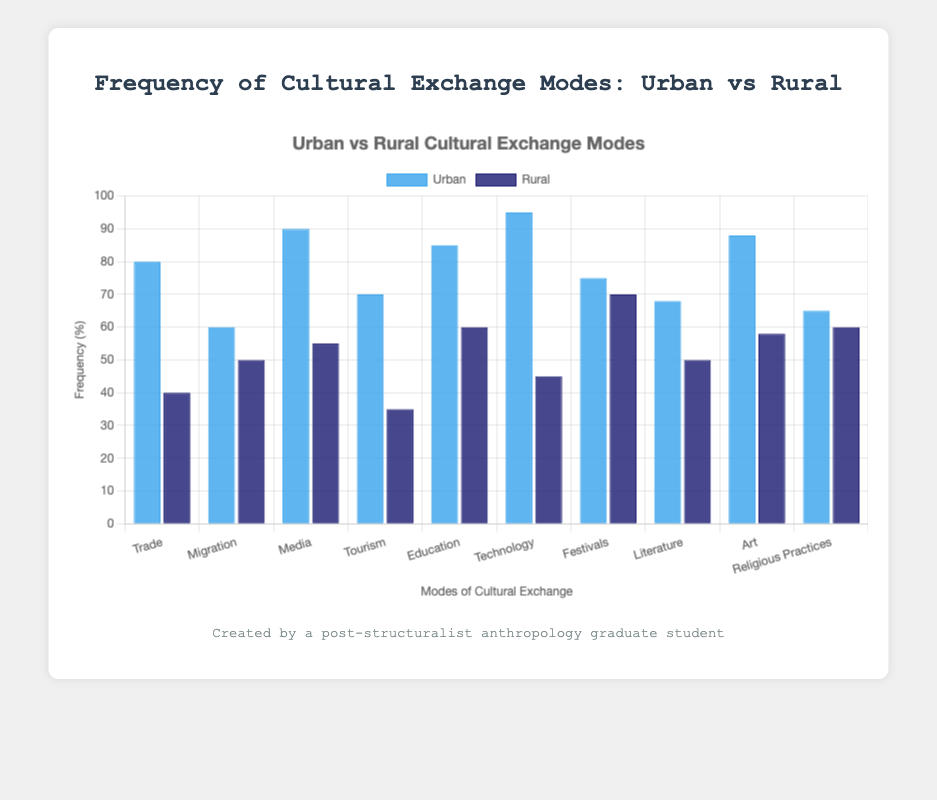What's the most frequent mode of cultural exchange in urban communities? The highest bar in the 'Urban' dataset corresponds to the mode with the greatest frequency. In this case, 'Technology' has a frequency of 95.
Answer: Technology What's the difference in the frequency of Media between urban and rural communities? To determine the difference, subtract the rural frequency from the urban frequency for the Media mode: 90 (urban) - 55 (rural) = 35.
Answer: 35 Which mode of cultural exchange has the least difference in frequency between urban and rural communities? Compare the absolute differences between the urban and rural frequencies across all modes. 'Festivals' has the least difference:
Answer: 5 How many modes have a higher frequency of cultural exchange in urban communities compared to rural communities? Count the number of modes where the urban bar is higher than the rural bar. This occurs in 'Trade', 'Media', 'Tourism', 'Education', 'Technology', 'Literature', and 'Art'.
Answer: 7 What is the average frequency of cultural exchange in rural communities for Education and Art? Add the frequencies of Education and Art in rural communities and divide by 2: (60 + 58) / 2 = 59.
Answer: 59 In which mode is the difference in frequency of cultural exchange exactly 30 between urban and rural communities? Compare each mode's urban and rural frequencies and find the mode where the difference is 30. This occurs with 'Trade' (80 - 40 = 40) and 'Technology' (95 - 45 = 50).
Answer: Trade, Technology Is the frequency of cultural exchange through Migration higher in urban or rural communities? Compare the heights of the Migration bars in urban (60) and rural (50) datasets. Urban is higher.
Answer: Urban Which mode of cultural exchange in rural communities has the highest frequency? The highest bar in the 'Rural' dataset corresponds to the mode with the greatest frequency. 'Festivals' has the highest frequency at 70.
Answer: Festivals What is the sum of the frequencies for Media and Literature modes in urban communities? Add the frequencies of Media and Literature in urban communities: 90 (Media) + 68 (Literature) = 158.
Answer: 158 What's the percentage difference in frequency for Tourism between urban and rural communities? Calculate the percentage difference based on the values: ((70 - 35) / 70) * 100 = 50%.
Answer: 50% 